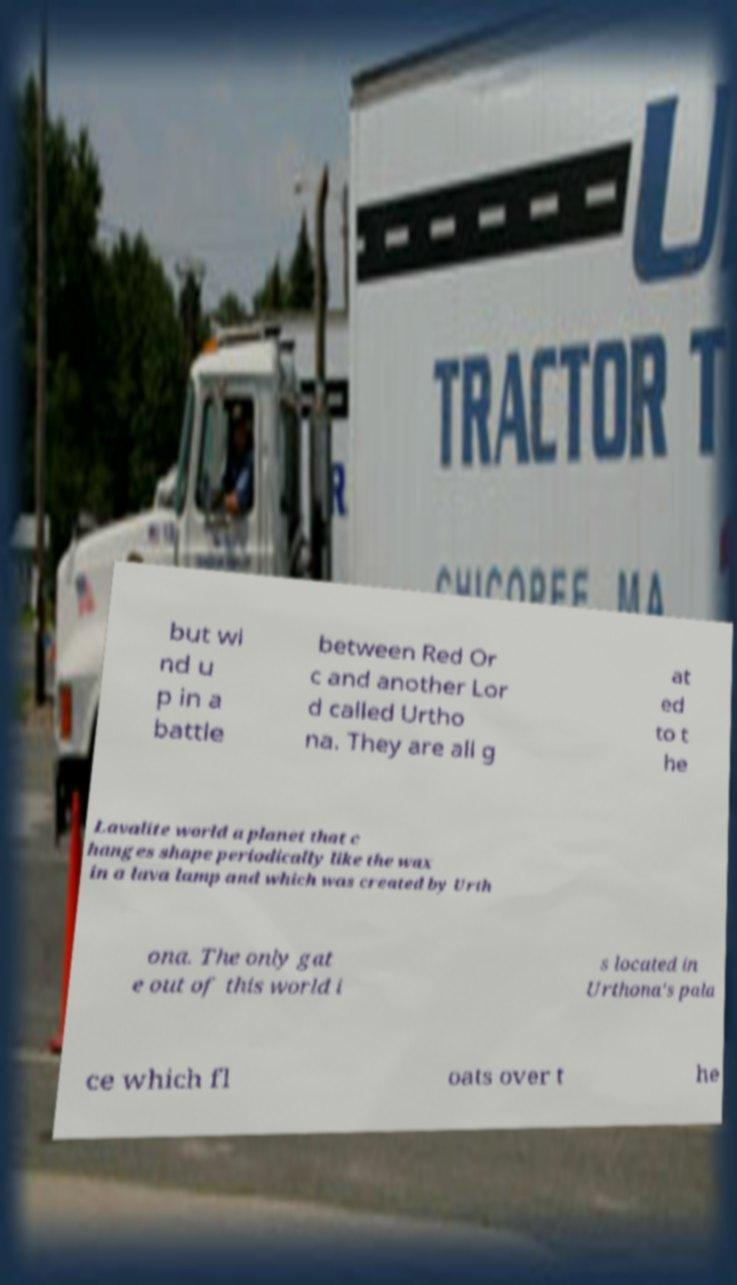Please identify and transcribe the text found in this image. but wi nd u p in a battle between Red Or c and another Lor d called Urtho na. They are all g at ed to t he Lavalite world a planet that c hanges shape periodically like the wax in a lava lamp and which was created by Urth ona. The only gat e out of this world i s located in Urthona's pala ce which fl oats over t he 